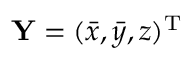<formula> <loc_0><loc_0><loc_500><loc_500>{ \mathbf Y } = ( \bar { x } , \bar { y } , z ) ^ { \mathrm T }</formula> 